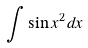Convert formula to latex. <formula><loc_0><loc_0><loc_500><loc_500>\int \sin x ^ { 2 } d x</formula> 